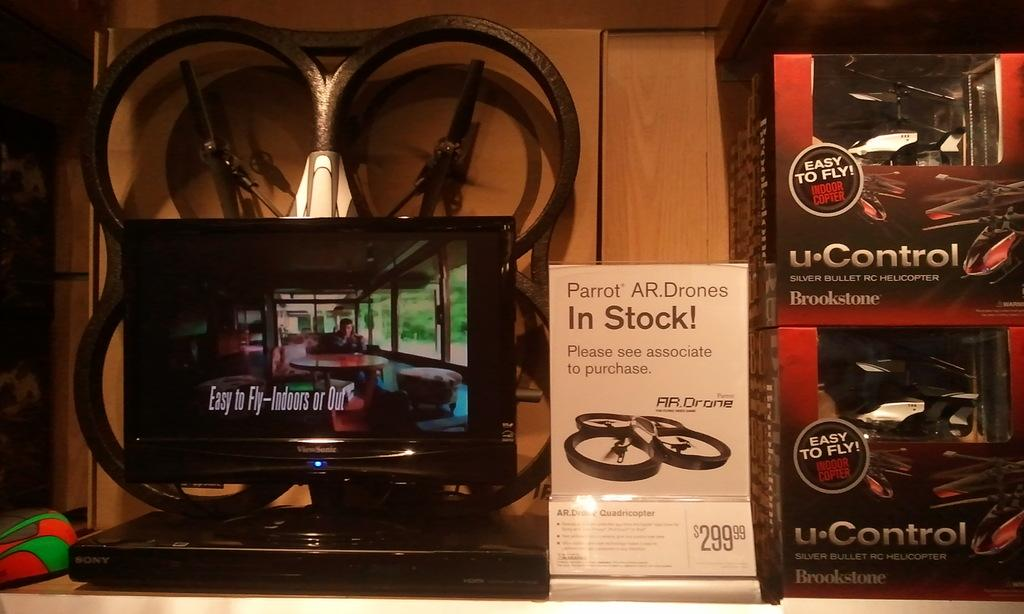<image>
Summarize the visual content of the image. A shelf has a portable DVD player on it and drones with a sign that says Parrot AR Drones In Stock. 